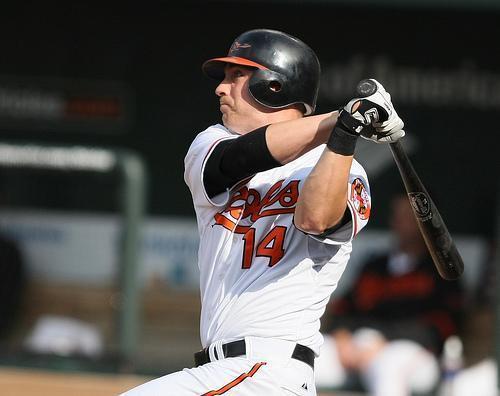How many people are in the photo?
Give a very brief answer. 1. 